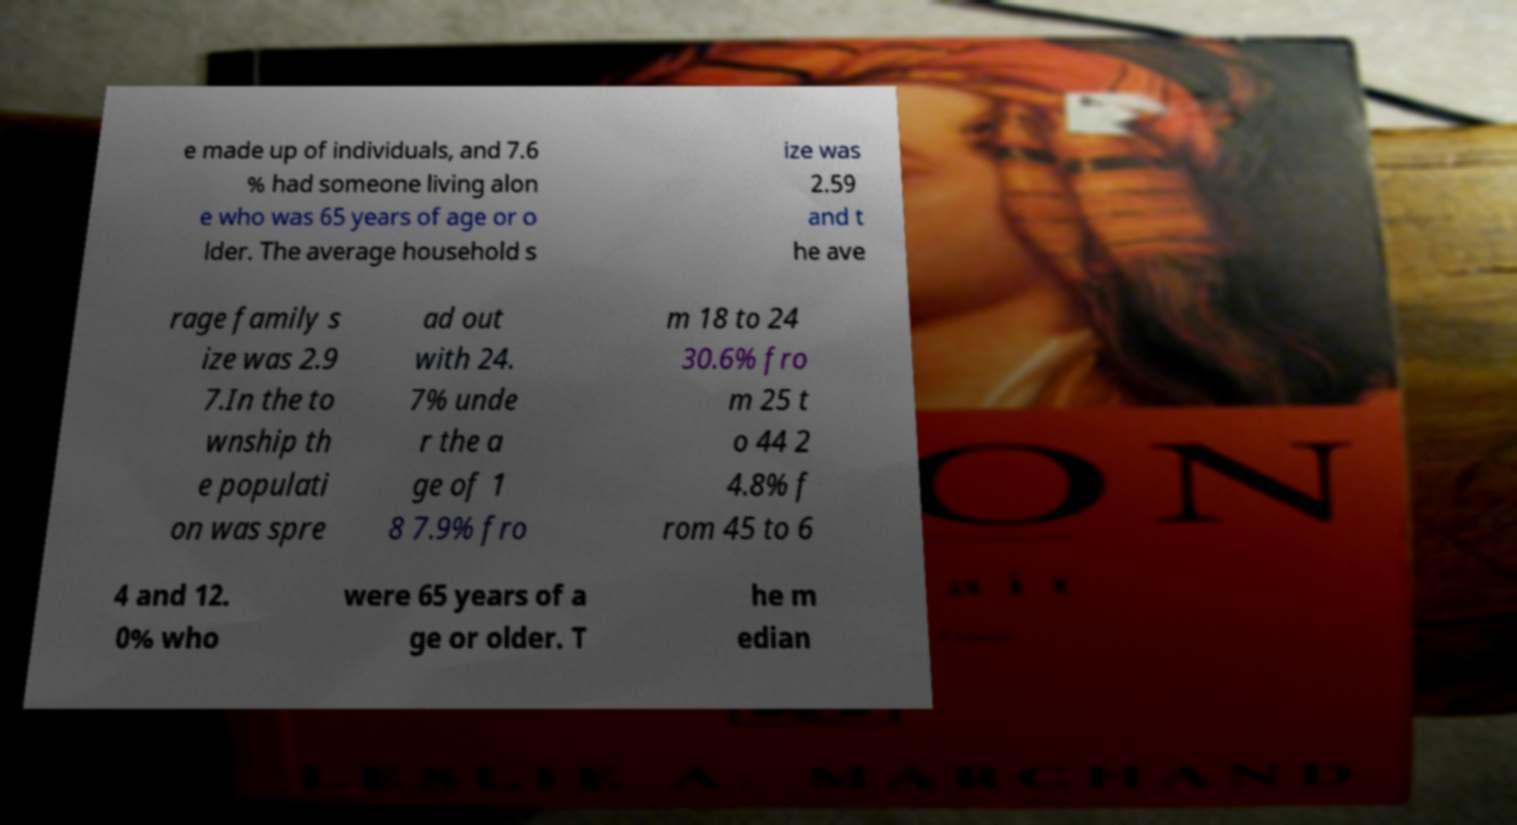There's text embedded in this image that I need extracted. Can you transcribe it verbatim? e made up of individuals, and 7.6 % had someone living alon e who was 65 years of age or o lder. The average household s ize was 2.59 and t he ave rage family s ize was 2.9 7.In the to wnship th e populati on was spre ad out with 24. 7% unde r the a ge of 1 8 7.9% fro m 18 to 24 30.6% fro m 25 t o 44 2 4.8% f rom 45 to 6 4 and 12. 0% who were 65 years of a ge or older. T he m edian 